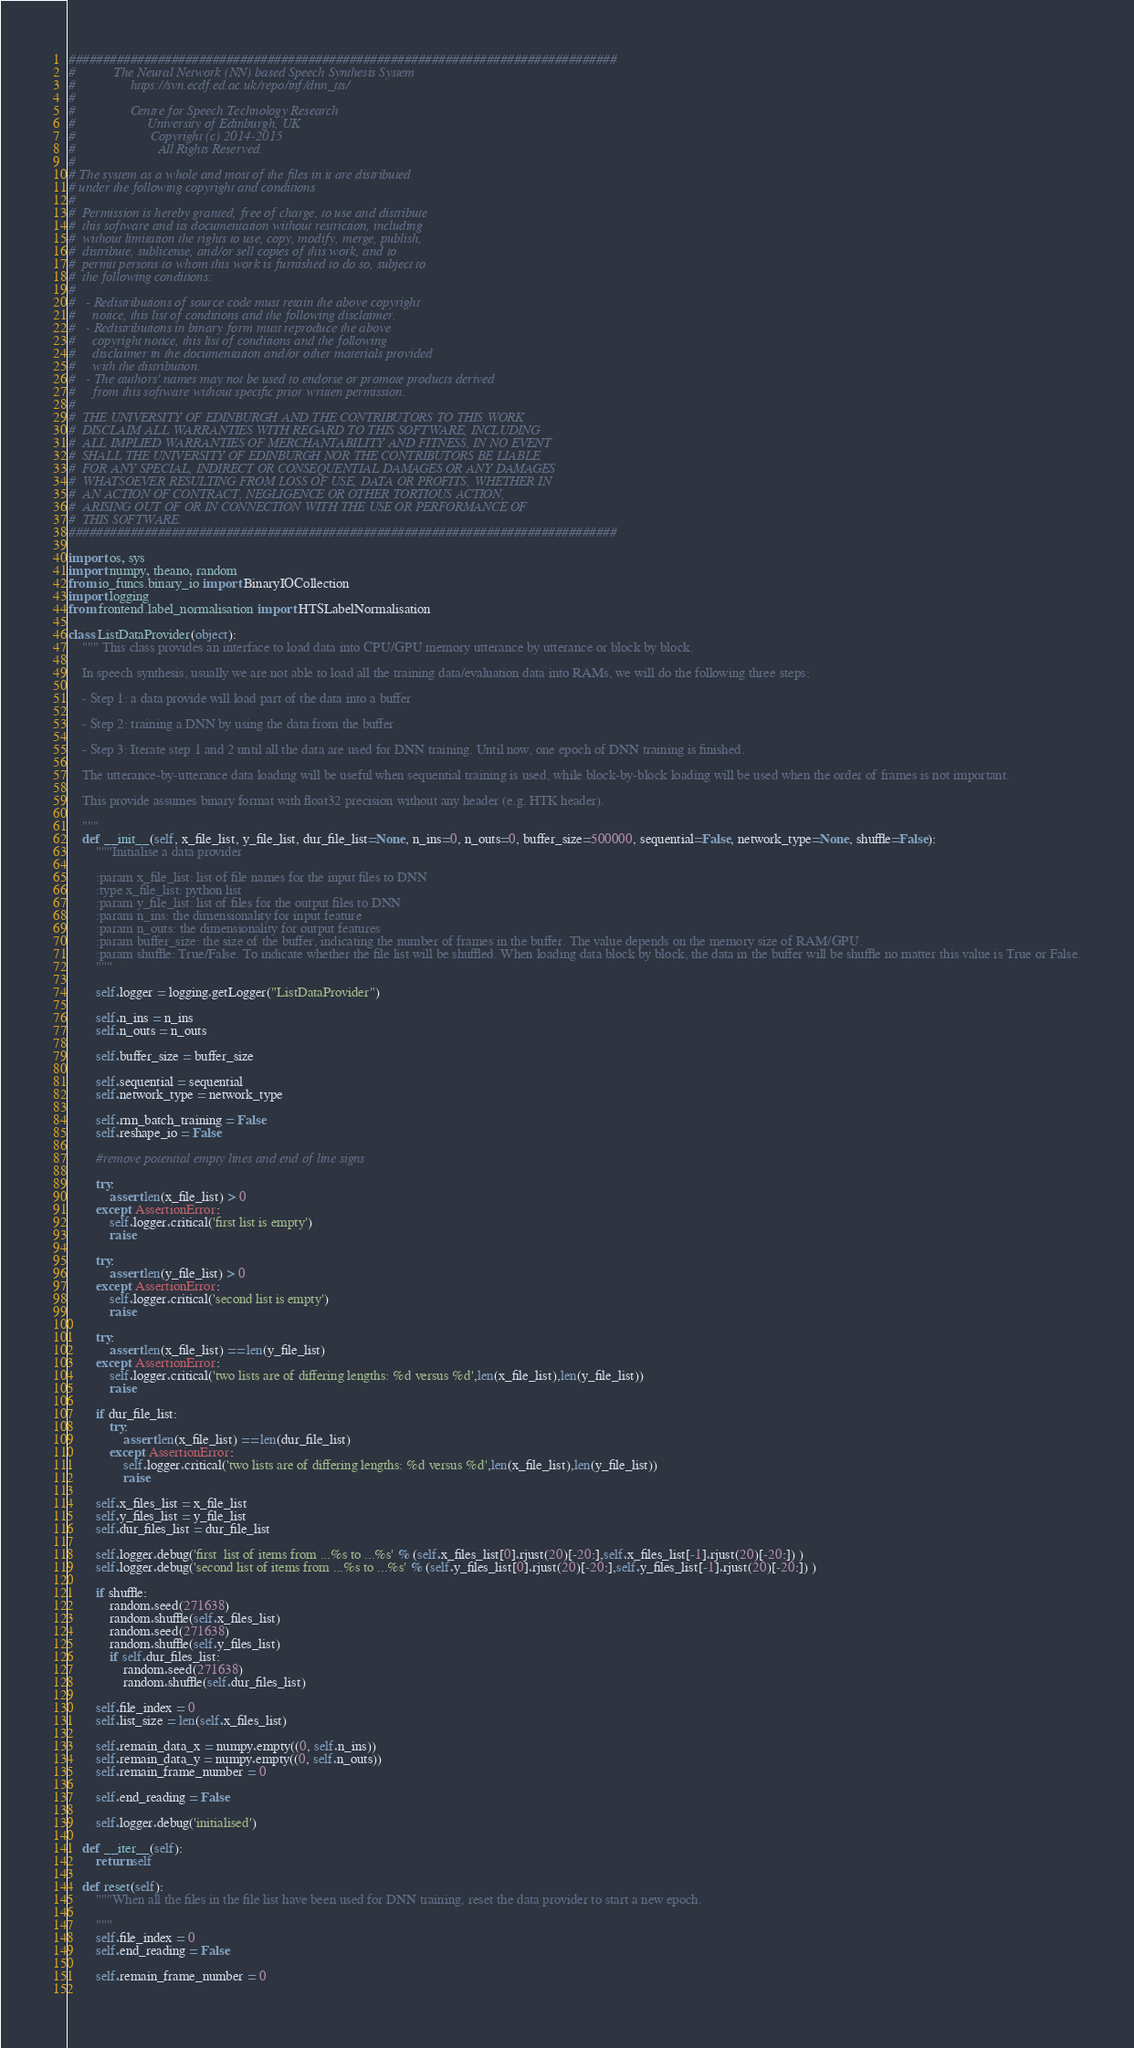Convert code to text. <code><loc_0><loc_0><loc_500><loc_500><_Python_>################################################################################
#           The Neural Network (NN) based Speech Synthesis System
#                https://svn.ecdf.ed.ac.uk/repo/inf/dnn_tts/
#
#                Centre for Speech Technology Research
#                     University of Edinburgh, UK
#                      Copyright (c) 2014-2015
#                        All Rights Reserved.
#
# The system as a whole and most of the files in it are distributed
# under the following copyright and conditions
#
#  Permission is hereby granted, free of charge, to use and distribute
#  this software and its documentation without restriction, including
#  without limitation the rights to use, copy, modify, merge, publish,
#  distribute, sublicense, and/or sell copies of this work, and to
#  permit persons to whom this work is furnished to do so, subject to
#  the following conditions:
#
#   - Redistributions of source code must retain the above copyright
#     notice, this list of conditions and the following disclaimer.
#   - Redistributions in binary form must reproduce the above
#     copyright notice, this list of conditions and the following
#     disclaimer in the documentation and/or other materials provided
#     with the distribution.
#   - The authors' names may not be used to endorse or promote products derived
#     from this software without specific prior written permission.
#
#  THE UNIVERSITY OF EDINBURGH AND THE CONTRIBUTORS TO THIS WORK
#  DISCLAIM ALL WARRANTIES WITH REGARD TO THIS SOFTWARE, INCLUDING
#  ALL IMPLIED WARRANTIES OF MERCHANTABILITY AND FITNESS, IN NO EVENT
#  SHALL THE UNIVERSITY OF EDINBURGH NOR THE CONTRIBUTORS BE LIABLE
#  FOR ANY SPECIAL, INDIRECT OR CONSEQUENTIAL DAMAGES OR ANY DAMAGES
#  WHATSOEVER RESULTING FROM LOSS OF USE, DATA OR PROFITS, WHETHER IN
#  AN ACTION OF CONTRACT, NEGLIGENCE OR OTHER TORTIOUS ACTION,
#  ARISING OUT OF OR IN CONNECTION WITH THE USE OR PERFORMANCE OF
#  THIS SOFTWARE.
################################################################################

import os, sys
import numpy, theano, random
from io_funcs.binary_io import BinaryIOCollection
import logging
from frontend.label_normalisation import HTSLabelNormalisation

class ListDataProvider(object):
    """ This class provides an interface to load data into CPU/GPU memory utterance by utterance or block by block.

    In speech synthesis, usually we are not able to load all the training data/evaluation data into RAMs, we will do the following three steps:

    - Step 1: a data provide will load part of the data into a buffer

    - Step 2: training a DNN by using the data from the buffer

    - Step 3: Iterate step 1 and 2 until all the data are used for DNN training. Until now, one epoch of DNN training is finished.

    The utterance-by-utterance data loading will be useful when sequential training is used, while block-by-block loading will be used when the order of frames is not important.

    This provide assumes binary format with float32 precision without any header (e.g. HTK header).

    """
    def __init__(self, x_file_list, y_file_list, dur_file_list=None, n_ins=0, n_outs=0, buffer_size=500000, sequential=False, network_type=None, shuffle=False):
        """Initialise a data provider

        :param x_file_list: list of file names for the input files to DNN
        :type x_file_list: python list
        :param y_file_list: list of files for the output files to DNN
        :param n_ins: the dimensionality for input feature
        :param n_outs: the dimensionality for output features
        :param buffer_size: the size of the buffer, indicating the number of frames in the buffer. The value depends on the memory size of RAM/GPU.
        :param shuffle: True/False. To indicate whether the file list will be shuffled. When loading data block by block, the data in the buffer will be shuffle no matter this value is True or False.
        """

        self.logger = logging.getLogger("ListDataProvider")

        self.n_ins = n_ins
        self.n_outs = n_outs

        self.buffer_size = buffer_size

        self.sequential = sequential
        self.network_type = network_type

        self.rnn_batch_training = False
        self.reshape_io = False

        #remove potential empty lines and end of line signs

        try:
            assert len(x_file_list) > 0
        except AssertionError:
            self.logger.critical('first list is empty')
            raise

        try:
            assert len(y_file_list) > 0
        except AssertionError:
            self.logger.critical('second list is empty')
            raise

        try:
            assert len(x_file_list) == len(y_file_list)
        except AssertionError:
            self.logger.critical('two lists are of differing lengths: %d versus %d',len(x_file_list),len(y_file_list))
            raise

        if dur_file_list:
            try:
                assert len(x_file_list) == len(dur_file_list)
            except AssertionError:
                self.logger.critical('two lists are of differing lengths: %d versus %d',len(x_file_list),len(y_file_list))
                raise

        self.x_files_list = x_file_list
        self.y_files_list = y_file_list
        self.dur_files_list = dur_file_list

        self.logger.debug('first  list of items from ...%s to ...%s' % (self.x_files_list[0].rjust(20)[-20:],self.x_files_list[-1].rjust(20)[-20:]) )
        self.logger.debug('second list of items from ...%s to ...%s' % (self.y_files_list[0].rjust(20)[-20:],self.y_files_list[-1].rjust(20)[-20:]) )

        if shuffle:
            random.seed(271638)
            random.shuffle(self.x_files_list)
            random.seed(271638)
            random.shuffle(self.y_files_list)
            if self.dur_files_list:
                random.seed(271638)
                random.shuffle(self.dur_files_list)

        self.file_index = 0
        self.list_size = len(self.x_files_list)

        self.remain_data_x = numpy.empty((0, self.n_ins))
        self.remain_data_y = numpy.empty((0, self.n_outs))
        self.remain_frame_number = 0

        self.end_reading = False

        self.logger.debug('initialised')

    def __iter__(self):
        return self

    def reset(self):
        """When all the files in the file list have been used for DNN training, reset the data provider to start a new epoch.

        """
        self.file_index = 0
        self.end_reading = False

        self.remain_frame_number = 0
        </code> 